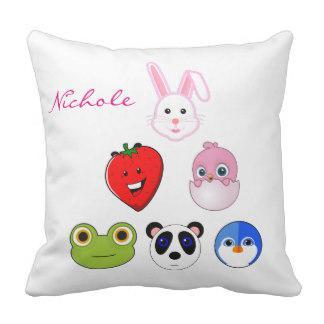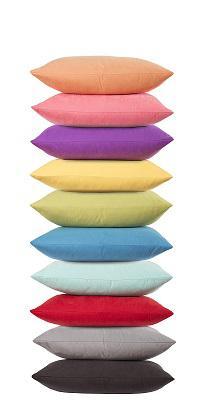The first image is the image on the left, the second image is the image on the right. Examine the images to the left and right. Is the description "The right image is a stack of at least 7 multicolored pillows, while the left image is a single square shaped pillow." accurate? Answer yes or no. Yes. The first image is the image on the left, the second image is the image on the right. Evaluate the accuracy of this statement regarding the images: "An image shows a four-sided pillow shape with at least one animal image on it.". Is it true? Answer yes or no. Yes. 